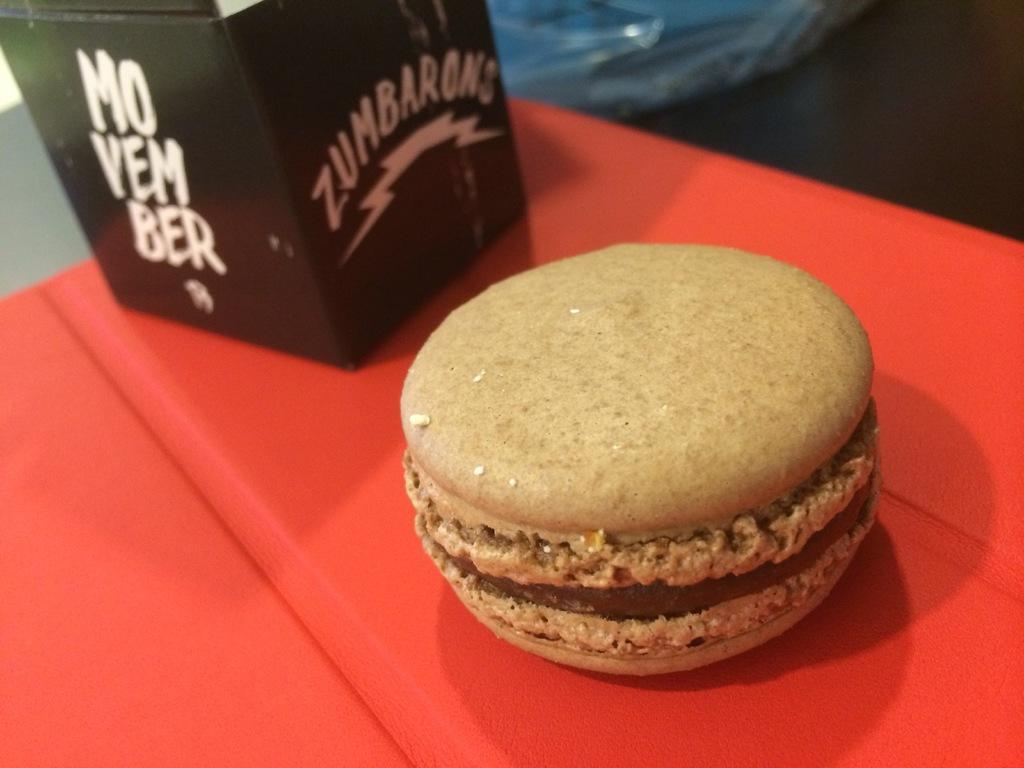How would you summarize this image in a sentence or two? In this image I can see a food item and a black box on a red surface. 